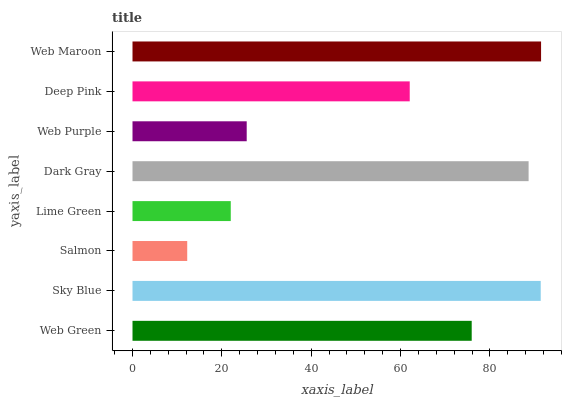Is Salmon the minimum?
Answer yes or no. Yes. Is Web Maroon the maximum?
Answer yes or no. Yes. Is Sky Blue the minimum?
Answer yes or no. No. Is Sky Blue the maximum?
Answer yes or no. No. Is Sky Blue greater than Web Green?
Answer yes or no. Yes. Is Web Green less than Sky Blue?
Answer yes or no. Yes. Is Web Green greater than Sky Blue?
Answer yes or no. No. Is Sky Blue less than Web Green?
Answer yes or no. No. Is Web Green the high median?
Answer yes or no. Yes. Is Deep Pink the low median?
Answer yes or no. Yes. Is Web Maroon the high median?
Answer yes or no. No. Is Dark Gray the low median?
Answer yes or no. No. 